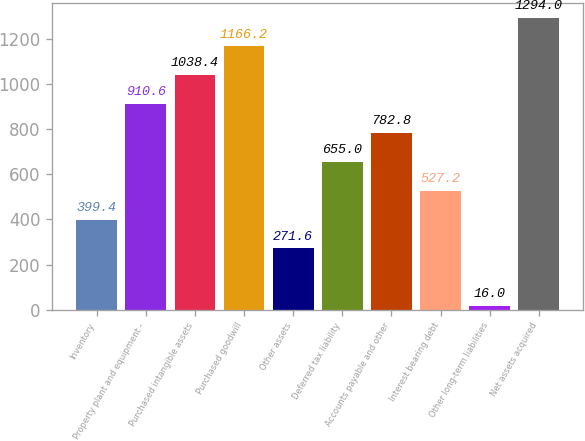<chart> <loc_0><loc_0><loc_500><loc_500><bar_chart><fcel>Inventory<fcel>Property plant and equipment -<fcel>Purchased intangible assets<fcel>Purchased goodwill<fcel>Other assets<fcel>Deferred tax liability<fcel>Accounts payable and other<fcel>Interest bearing debt<fcel>Other long-term liabilities<fcel>Net assets acquired<nl><fcel>399.4<fcel>910.6<fcel>1038.4<fcel>1166.2<fcel>271.6<fcel>655<fcel>782.8<fcel>527.2<fcel>16<fcel>1294<nl></chart> 